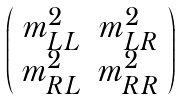<formula> <loc_0><loc_0><loc_500><loc_500>\left ( \begin{array} { c c } m ^ { 2 } _ { L L } & m ^ { 2 } _ { L R } \\ m ^ { 2 } _ { R L } & m ^ { 2 } _ { R R } \\ \end{array} \right )</formula> 